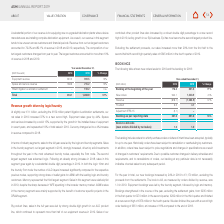According to Asm International Nv's financial document, What was the percentage increase in new bookings in 2019 for the year in total? According to the financial document, 24%. The relevant text states: "r the year in total, our new bookings increased by 24% in 2019 to €1,170 million, excluding the..." Also, What does the table show? new orders levels for 2019 and the backlog for 2018. The document states: "The following table shows new orders levels for 2019 and the backlog for 2018:..." Also, What is the % change in Backlog at the beginning of the year from 2018 to 2019? According to the financial document, 71%. The relevant text states: "Backlog at the beginning of the year 176.3 301.5 71%..." Also, can you calculate: What is the average Backlog at the beginning of the year for both 2018 and 2019? To answer this question, I need to perform calculations using the financial data. The calculation is: (176.3+301.5)/2, which equals 238.9 (in millions). This is based on the information: "Backlog at the beginning of the year 176.3 301.5 71% Backlog at the beginning of the year 176.3 301.5 71%..." The key data points involved are: 176.3, 301.5. Also, can you calculate: What is the percentage change in Bookings, excluding the settlement gains of first quarter 2019 to second quarter? To answer this question, I need to perform calculations using the financial data. The calculation is: (270-235)/235, which equals 14.89 (percentage). This is based on the information: "f the year, excluding the settlement gains, from €235 million in the first quarter to €270 million in the second quarter, €292 million in the third quarter and finished..." The key data points involved are: 235, 270. Also, can you calculate: What is the percentage change in Bookings, excluding the settlement gains, of the first two quarters 2019 to last two quarters? To answer this question, I need to perform calculations using the financial data. The calculation is: (373+292-270-235)/(235+270), which equals 31.68 (percentage). This is based on the information: "at a new record high of €373 million in the fourth quarter. We also finished the year with a record high t quarter to €270 million in the second quarter, €292 million in the third quarter and finished..." The key data points involved are: 235, 270, 292. 